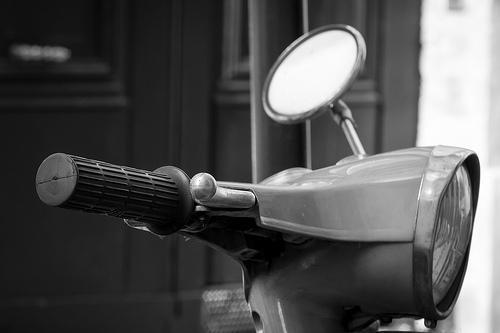How many headlights are in the photo?
Give a very brief answer. 1. How many motorcycles are in the foreground?
Give a very brief answer. 1. 